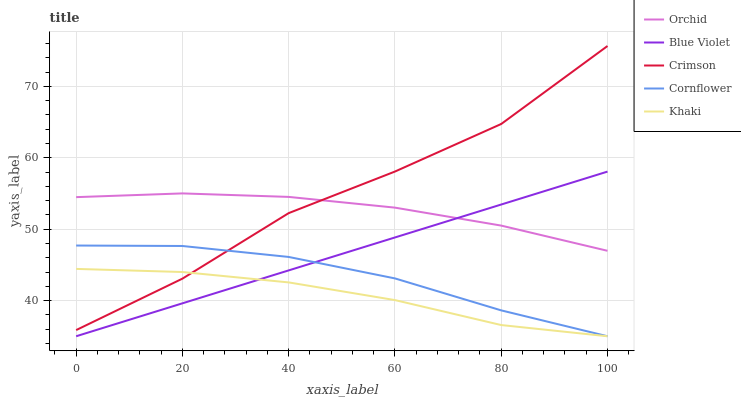Does Khaki have the minimum area under the curve?
Answer yes or no. Yes. Does Crimson have the maximum area under the curve?
Answer yes or no. Yes. Does Cornflower have the minimum area under the curve?
Answer yes or no. No. Does Cornflower have the maximum area under the curve?
Answer yes or no. No. Is Blue Violet the smoothest?
Answer yes or no. Yes. Is Crimson the roughest?
Answer yes or no. Yes. Is Cornflower the smoothest?
Answer yes or no. No. Is Cornflower the roughest?
Answer yes or no. No. Does Cornflower have the lowest value?
Answer yes or no. Yes. Does Orchid have the lowest value?
Answer yes or no. No. Does Crimson have the highest value?
Answer yes or no. Yes. Does Cornflower have the highest value?
Answer yes or no. No. Is Blue Violet less than Crimson?
Answer yes or no. Yes. Is Orchid greater than Cornflower?
Answer yes or no. Yes. Does Cornflower intersect Khaki?
Answer yes or no. Yes. Is Cornflower less than Khaki?
Answer yes or no. No. Is Cornflower greater than Khaki?
Answer yes or no. No. Does Blue Violet intersect Crimson?
Answer yes or no. No. 